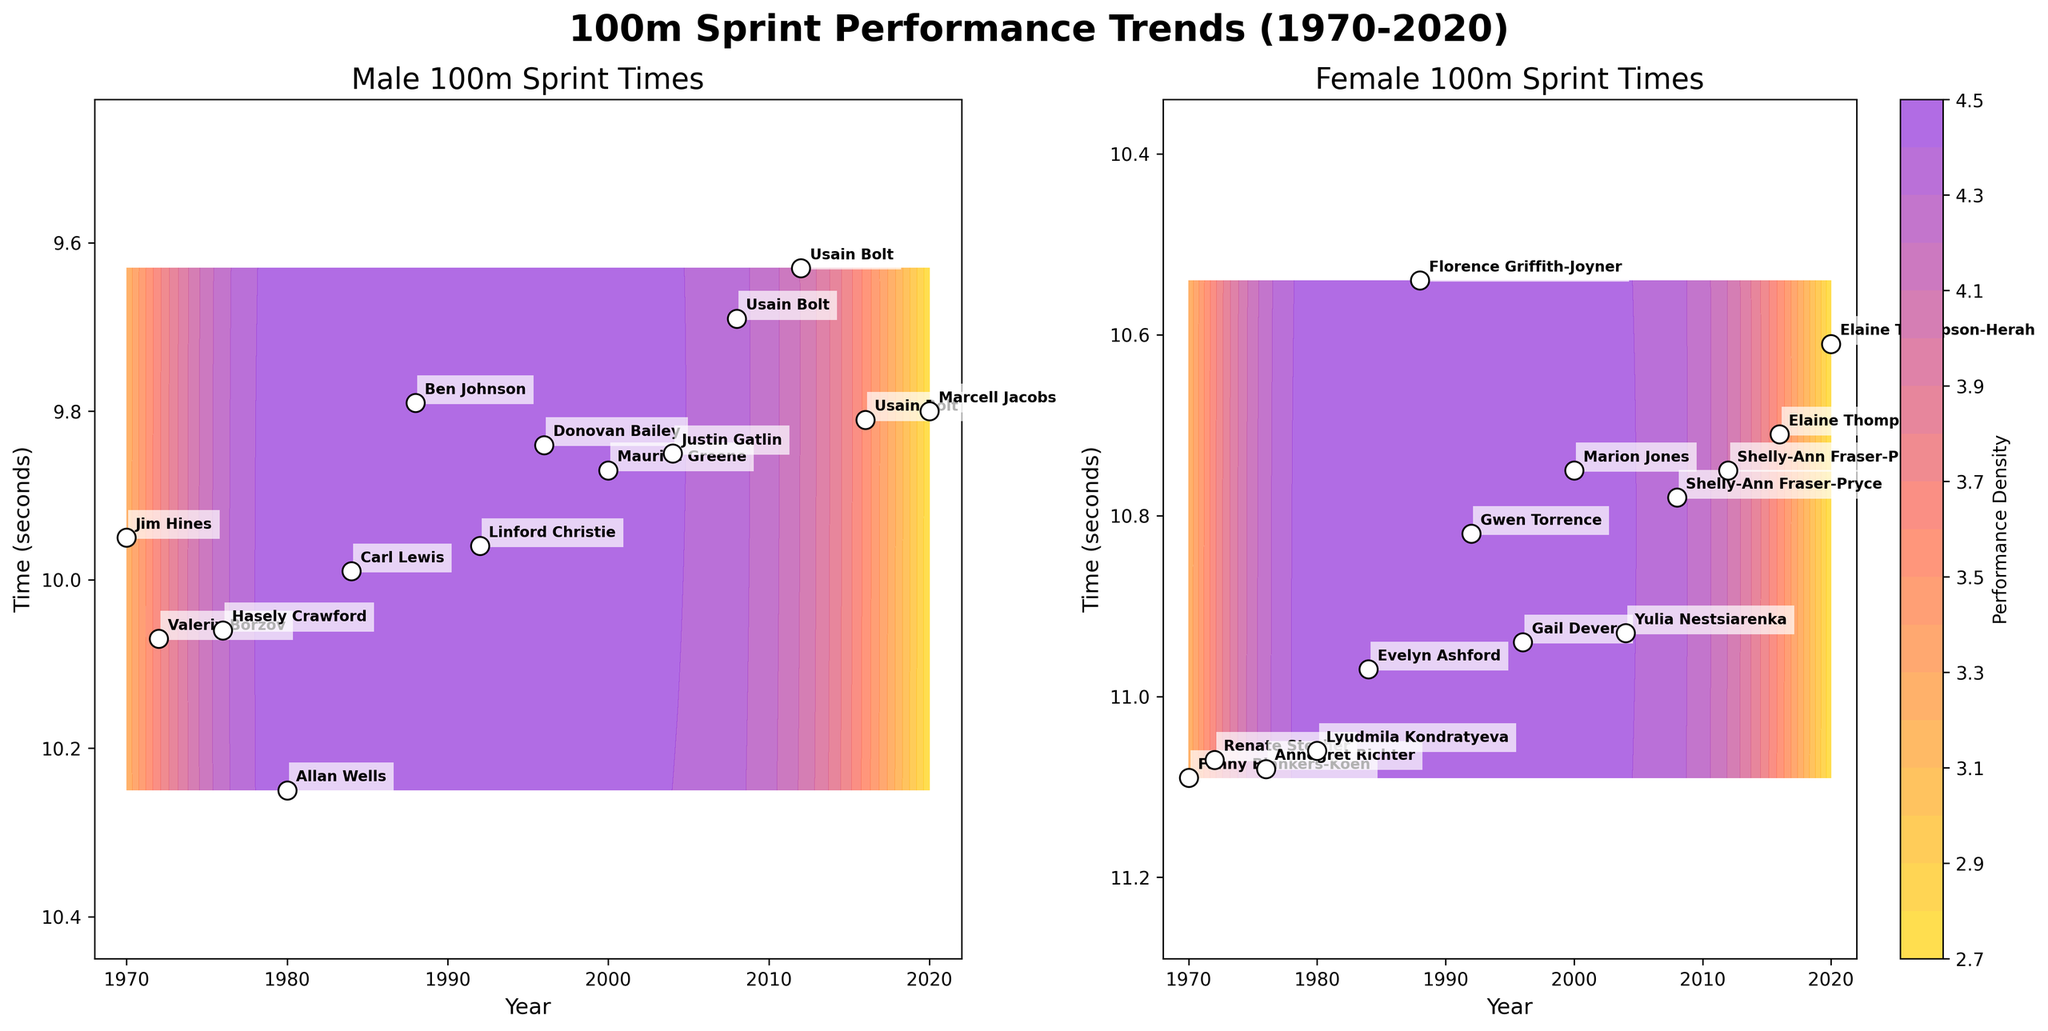What is the title of the figure? The title of the figure is placed at the top, prominently displayed. It reads '100m Sprint Performance Trends (1970-2020)'.
Answer: 100m Sprint Performance Trends (1970-2020) In the male athletes' subplot, which athlete has the fastest time? In the male subplot on the left, Usain Bolt has the fastest time in 2012 with a recorded time of 9.63 seconds.
Answer: Usain Bolt How does the trend of completion times for female athletes look from 1970 to 2020? In the female subplot on the right, the trend shows decreasing completion times from 1970 to 2020, indicating that the athletes' performance has improved over the years.
Answer: Decreasing Which year do we see the highest performance density for male athletes? Looking at the color density on the male subplot, the highest performance density appears around the years 2008 to 2012, indicated by the most intense region of the color gradient.
Answer: 2008 to 2012 Are there more athletes with completion times below 10 seconds in the male or female subgroup? By observing the distribution of points and their corresponding times in both subplots, more male athletes have completion times below 10 seconds compared to female athletes.
Answer: Male Which female athlete’s performance drastically improved the world record in the observed time range? The female subplot shows that Florence Griffith-Joyner in 1988 significantly improved the world record with a time of 10.54 seconds, a substantial drop from previous records.
Answer: Florence Griffith-Joyner How does the density contour suggest improvements over time for female athletes? The density contours on the female subplot shift towards lower times suggesting consistent performance improvements over the years.
Answer: Shift towards lower times Compare the fastest times of male and female athletes in the year 1984. From both subplots, Carl Lewis had the fastest time for male athletes with 9.99 seconds, and Evelyn Ashford had the fastest time for female athletes with 10.97 seconds in 1984.
Answer: Male: 9.99s, Female: 10.97s What is the general difference in performance trends between male and female athletes? Both subplots indicate a trend of improving times; however, male athletes show more aggressive performance improvements as indicated by the steeper downward trend and more intense contours.
Answer: More aggressive improvement in males What does the color gradient represent in the subplot? The color gradient in both subplots represents performance density, with darker colors indicating higher density of performance times for the years in question.
Answer: Performance density 